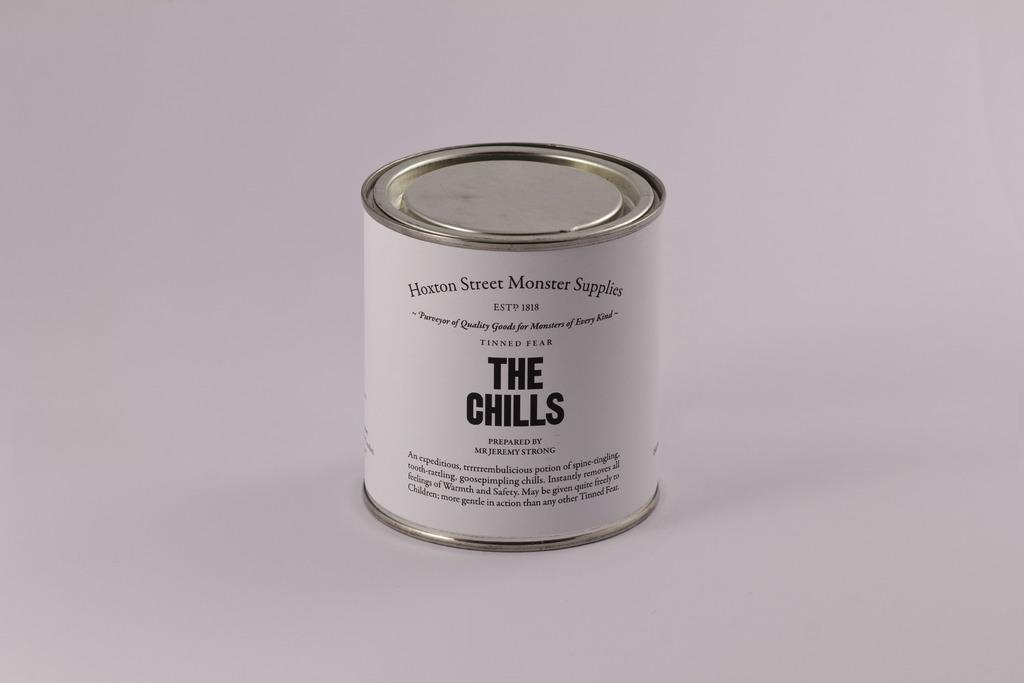Provide a one-sentence caption for the provided image. A can with a white label and black letters with the title, "The Chills.". 